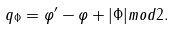Convert formula to latex. <formula><loc_0><loc_0><loc_500><loc_500>q _ { \Phi } = \varphi ^ { \prime } - \varphi + | \Phi | m o d 2 .</formula> 